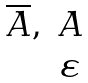Convert formula to latex. <formula><loc_0><loc_0><loc_500><loc_500>\begin{matrix} \overline { A } , & A \\ & \varepsilon \\ \end{matrix}</formula> 